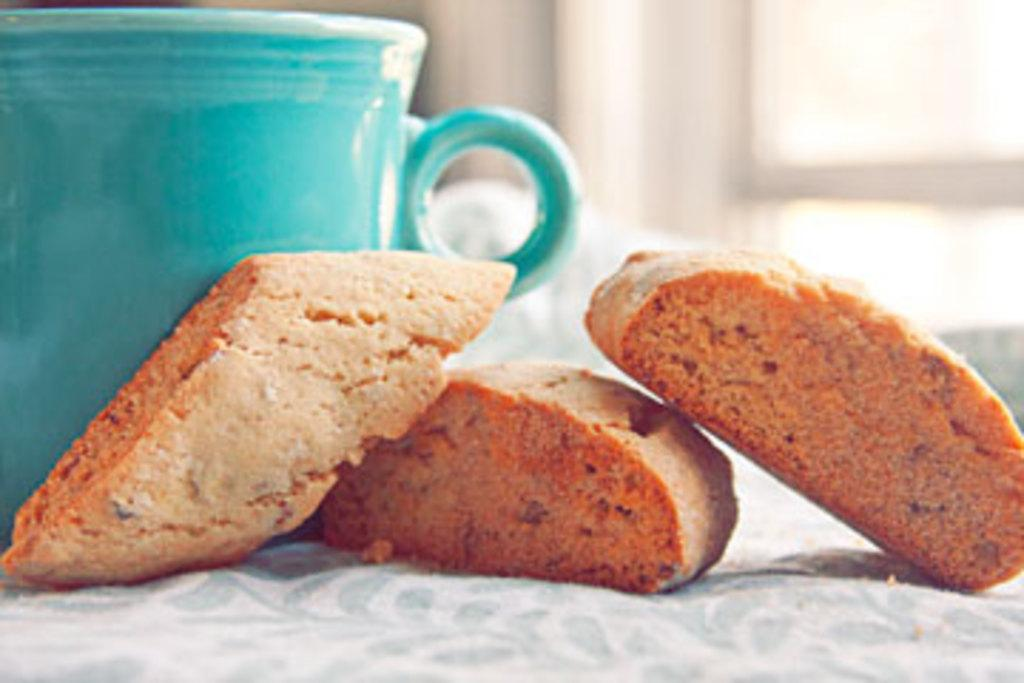What is covering the table in the image? The table is covered with a cloth in the image. What type of food items are on the table? There are biscuits on the table. What else can be seen on the table? There is a cup on the table. Can you describe the background of the image? The background of the image is blurred, but there is a window and a wall visible. Reasoning: Let's think step by step by step in order to produce the conversation. We start by identifying the main subject in the image, which is the table covered with a cloth. Then, we expand the conversation to include other items that are also visible, such as biscuits, a cup, and the background elements. Each question is designed to elicit a specific detail about the image that is known from the provided facts. Absurd Question/Answer: How many snails can be seen crawling on the table in the image? There are no snails present in the image; it only features a table covered with a cloth, biscuits, and a cup. Is there a sneeze visible in the image? There is no sneeze present in the image; it only features a table covered with a cloth, biscuits, and a cup. 